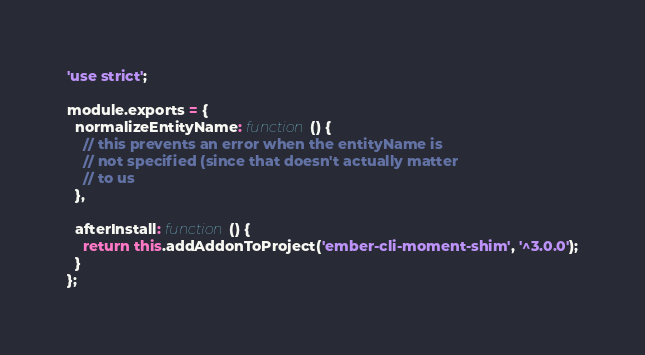Convert code to text. <code><loc_0><loc_0><loc_500><loc_500><_JavaScript_>'use strict';

module.exports = {
  normalizeEntityName: function() {
    // this prevents an error when the entityName is
    // not specified (since that doesn't actually matter
    // to us
  },

  afterInstall: function() {
    return this.addAddonToProject('ember-cli-moment-shim', '^3.0.0');
  }
};
</code> 